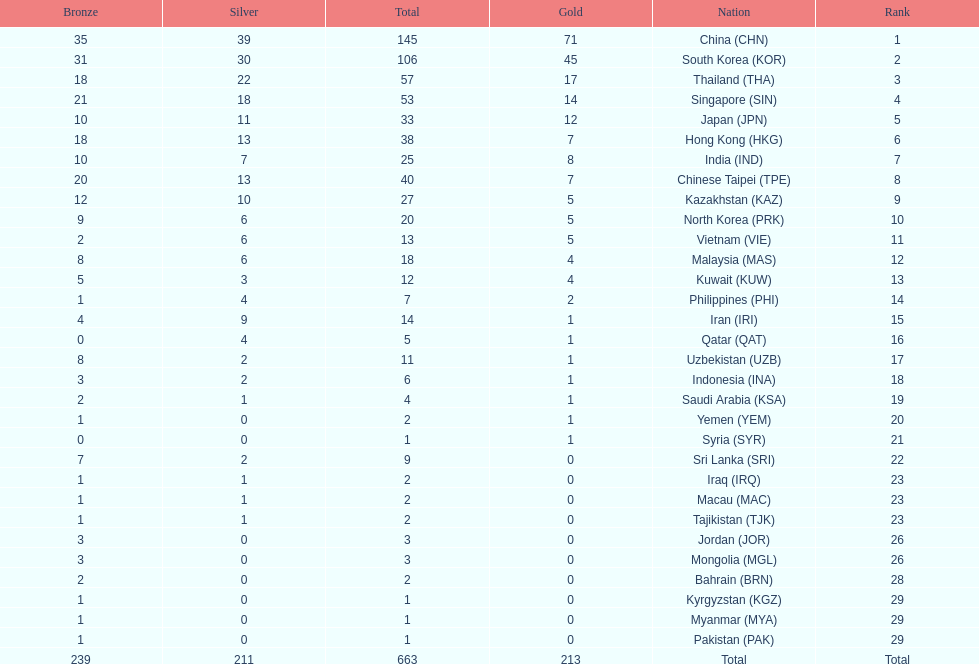How many nations earned at least ten bronze medals? 9. 